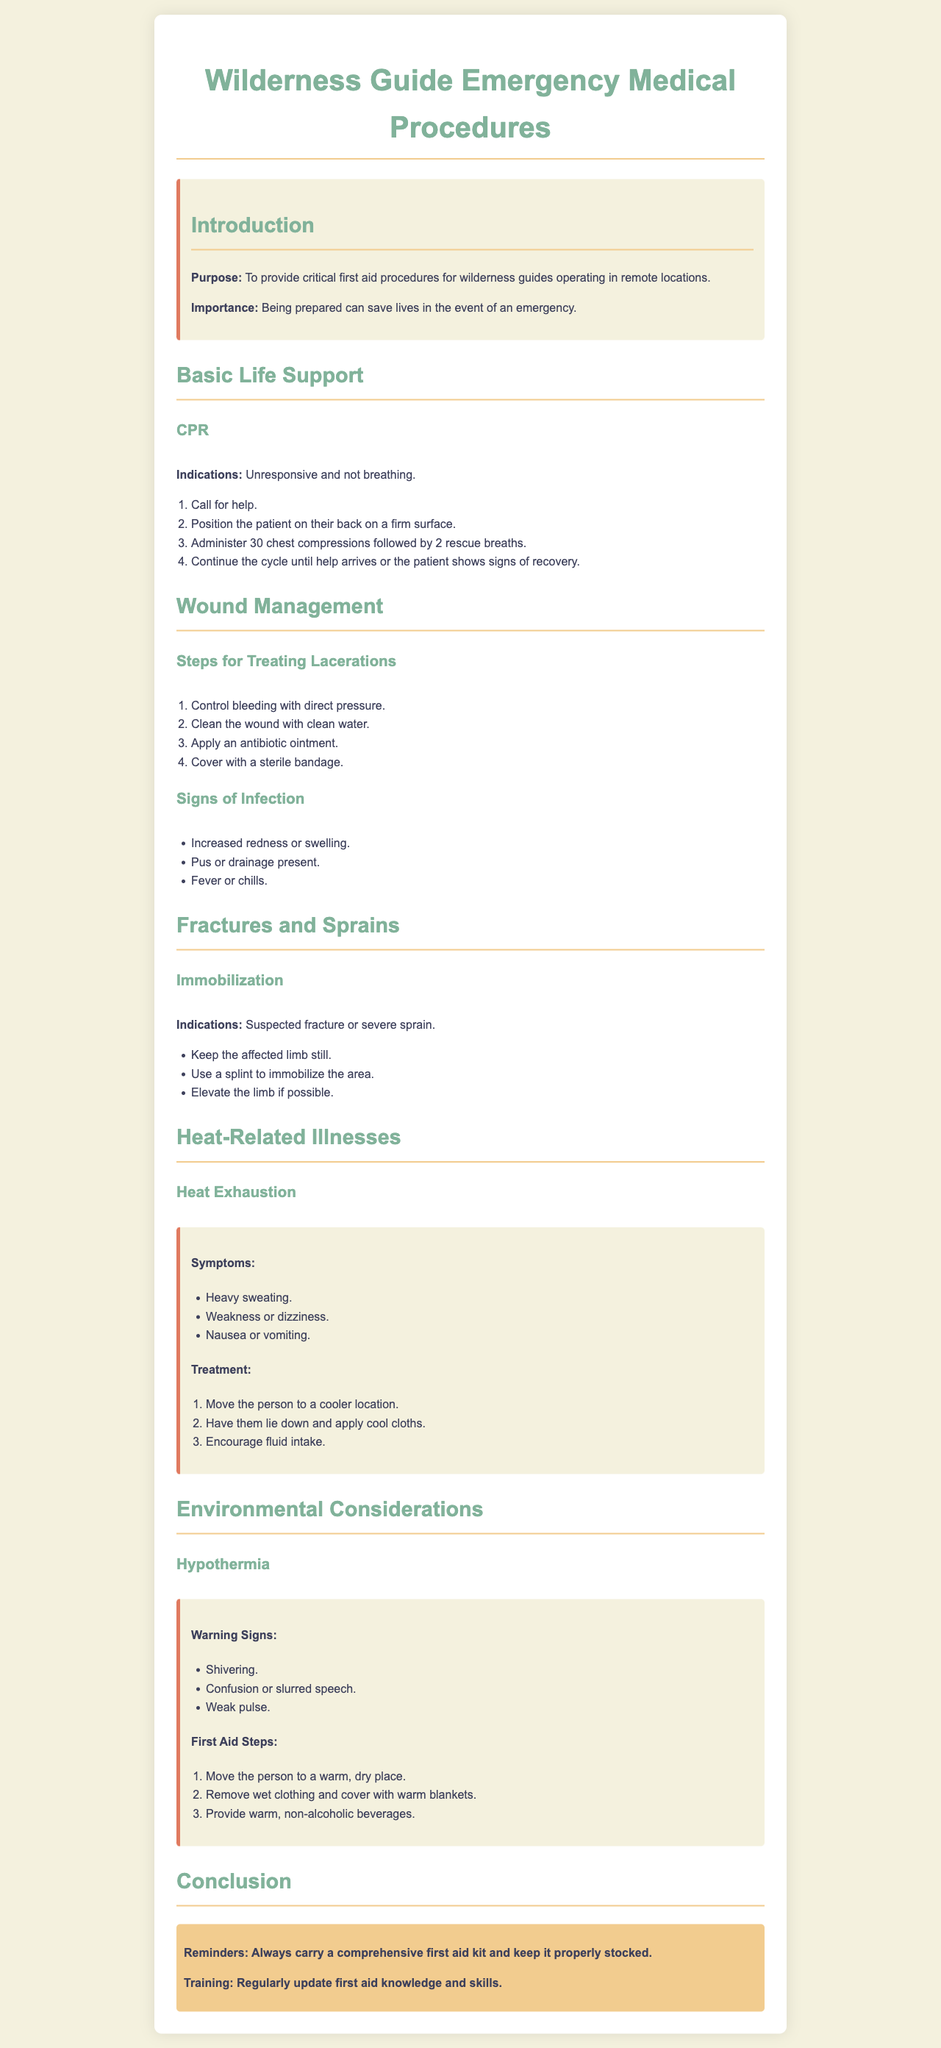What is the purpose of this guide? The purpose of the guide is to provide critical first aid procedures for wilderness guides operating in remote locations.
Answer: To provide critical first aid procedures for wilderness guides operating in remote locations What are the first three steps in performing CPR? The first three steps in performing CPR are: call for help, position the patient on their back on a firm surface, and administer 30 chest compressions followed by 2 rescue breaths.
Answer: Call for help, position the patient, administer compressions What are the signs of infection listed in the document? The signs of infection include increased redness or swelling, pus or drainage present, and fever or chills.
Answer: Increased redness or swelling, pus or drainage, fever or chills What is the recommended position for a person experiencing heat exhaustion? The recommended position for a person experiencing heat exhaustion is to lie down and apply cool cloths.
Answer: Lie down and apply cool cloths What should you do first if someone shows warning signs of hypothermia? The first step is to move the person to a warm, dry place.
Answer: Move the person to a warm, dry place What should be done to injured limbs suspected of being fractured? Injured limbs suspected of being fractured should be kept still and immobilized using a splint.
Answer: Keep the affected limb still and use a splint How often should first aid knowledge and skills be updated? The document implies that first aid knowledge and skills should be updated regularly.
Answer: Regularly What color is the highlight box at the end of the document? The highlight box is colored in a shade that corresponds with beige/yellow.
Answer: Beige/yellow 